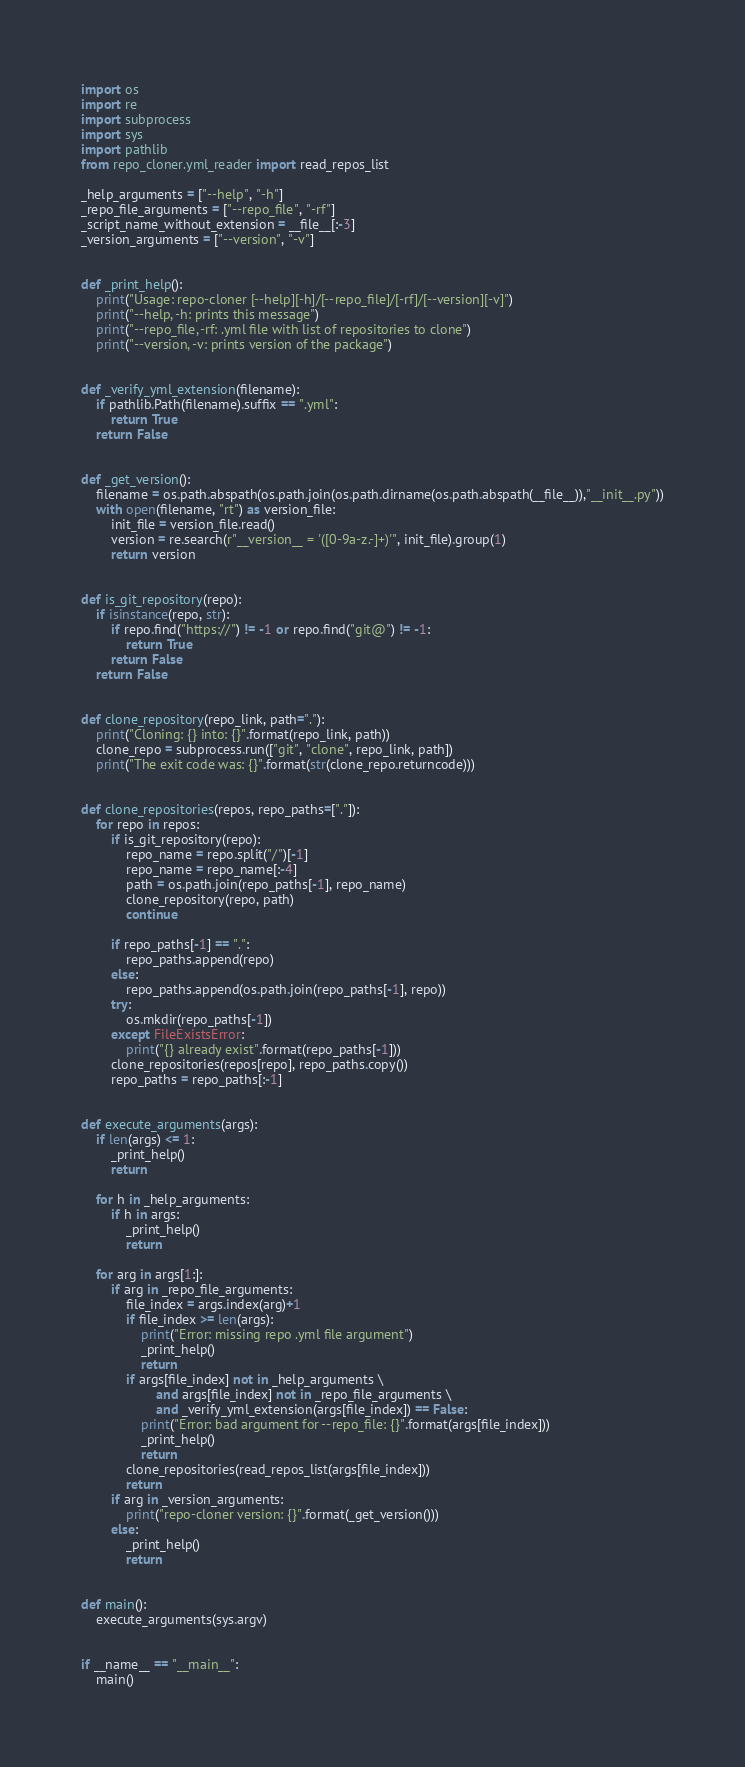Convert code to text. <code><loc_0><loc_0><loc_500><loc_500><_Python_>import os
import re
import subprocess
import sys
import pathlib
from repo_cloner.yml_reader import read_repos_list

_help_arguments = ["--help", "-h"]
_repo_file_arguments = ["--repo_file", "-rf"]
_script_name_without_extension = __file__[:-3]
_version_arguments = ["--version", "-v"]


def _print_help():
    print("Usage: repo-cloner [--help][-h]/[--repo_file]/[-rf]/[--version][-v]")
    print("--help, -h: prints this message")
    print("--repo_file, -rf: .yml file with list of repositories to clone")
    print("--version, -v: prints version of the package")


def _verify_yml_extension(filename):
    if pathlib.Path(filename).suffix == ".yml":
        return True
    return False


def _get_version():
    filename = os.path.abspath(os.path.join(os.path.dirname(os.path.abspath(__file__)),"__init__.py"))
    with open(filename, "rt") as version_file:
        init_file = version_file.read()
        version = re.search(r"__version__ = '([0-9a-z.-]+)'", init_file).group(1)
        return version


def is_git_repository(repo):
    if isinstance(repo, str):
        if repo.find("https://") != -1 or repo.find("git@") != -1:
            return True
        return False
    return False


def clone_repository(repo_link, path="."):
    print("Cloning: {} into: {}".format(repo_link, path))
    clone_repo = subprocess.run(["git", "clone", repo_link, path])
    print("The exit code was: {}".format(str(clone_repo.returncode)))


def clone_repositories(repos, repo_paths=["."]):
    for repo in repos:
        if is_git_repository(repo):
            repo_name = repo.split("/")[-1]
            repo_name = repo_name[:-4]
            path = os.path.join(repo_paths[-1], repo_name)
            clone_repository(repo, path)
            continue

        if repo_paths[-1] == ".":
            repo_paths.append(repo)
        else:
            repo_paths.append(os.path.join(repo_paths[-1], repo))
        try:
            os.mkdir(repo_paths[-1])
        except FileExistsError:
            print("{} already exist".format(repo_paths[-1]))
        clone_repositories(repos[repo], repo_paths.copy())
        repo_paths = repo_paths[:-1]


def execute_arguments(args):
    if len(args) <= 1:
        _print_help()
        return

    for h in _help_arguments:
        if h in args:
            _print_help()
            return

    for arg in args[1:]:
        if arg in _repo_file_arguments:
            file_index = args.index(arg)+1
            if file_index >= len(args):
                print("Error: missing repo .yml file argument")
                _print_help()
                return
            if args[file_index] not in _help_arguments \
                    and args[file_index] not in _repo_file_arguments \
                    and _verify_yml_extension(args[file_index]) == False:
                print("Error: bad argument for --repo_file: {}".format(args[file_index]))
                _print_help()
                return
            clone_repositories(read_repos_list(args[file_index]))
            return
        if arg in _version_arguments:
            print("repo-cloner version: {}".format(_get_version()))
        else:
            _print_help()
            return


def main():
    execute_arguments(sys.argv)


if __name__ == "__main__":
    main()
</code> 